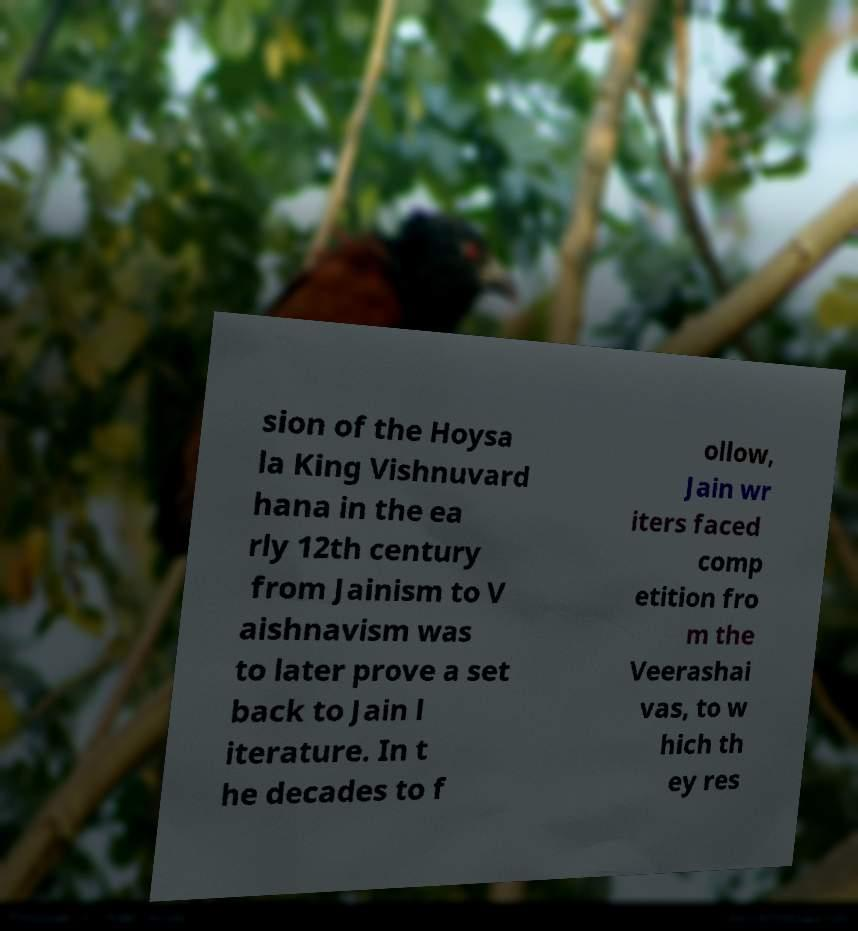Please read and relay the text visible in this image. What does it say? sion of the Hoysa la King Vishnuvard hana in the ea rly 12th century from Jainism to V aishnavism was to later prove a set back to Jain l iterature. In t he decades to f ollow, Jain wr iters faced comp etition fro m the Veerashai vas, to w hich th ey res 